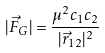Convert formula to latex. <formula><loc_0><loc_0><loc_500><loc_500>| \vec { F } _ { G } | = \frac { \mu ^ { 2 } c _ { 1 } c _ { 2 } } { | \vec { r } _ { 1 2 } | ^ { 2 } }</formula> 